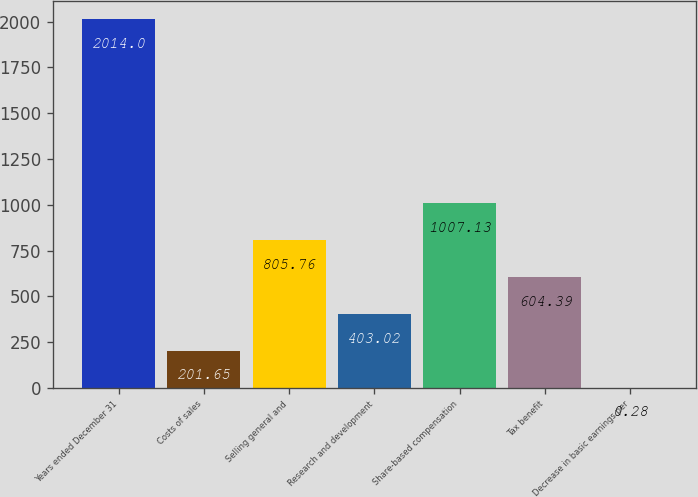Convert chart. <chart><loc_0><loc_0><loc_500><loc_500><bar_chart><fcel>Years ended December 31<fcel>Costs of sales<fcel>Selling general and<fcel>Research and development<fcel>Share-based compensation<fcel>Tax benefit<fcel>Decrease in basic earnings per<nl><fcel>2014<fcel>201.65<fcel>805.76<fcel>403.02<fcel>1007.13<fcel>604.39<fcel>0.28<nl></chart> 